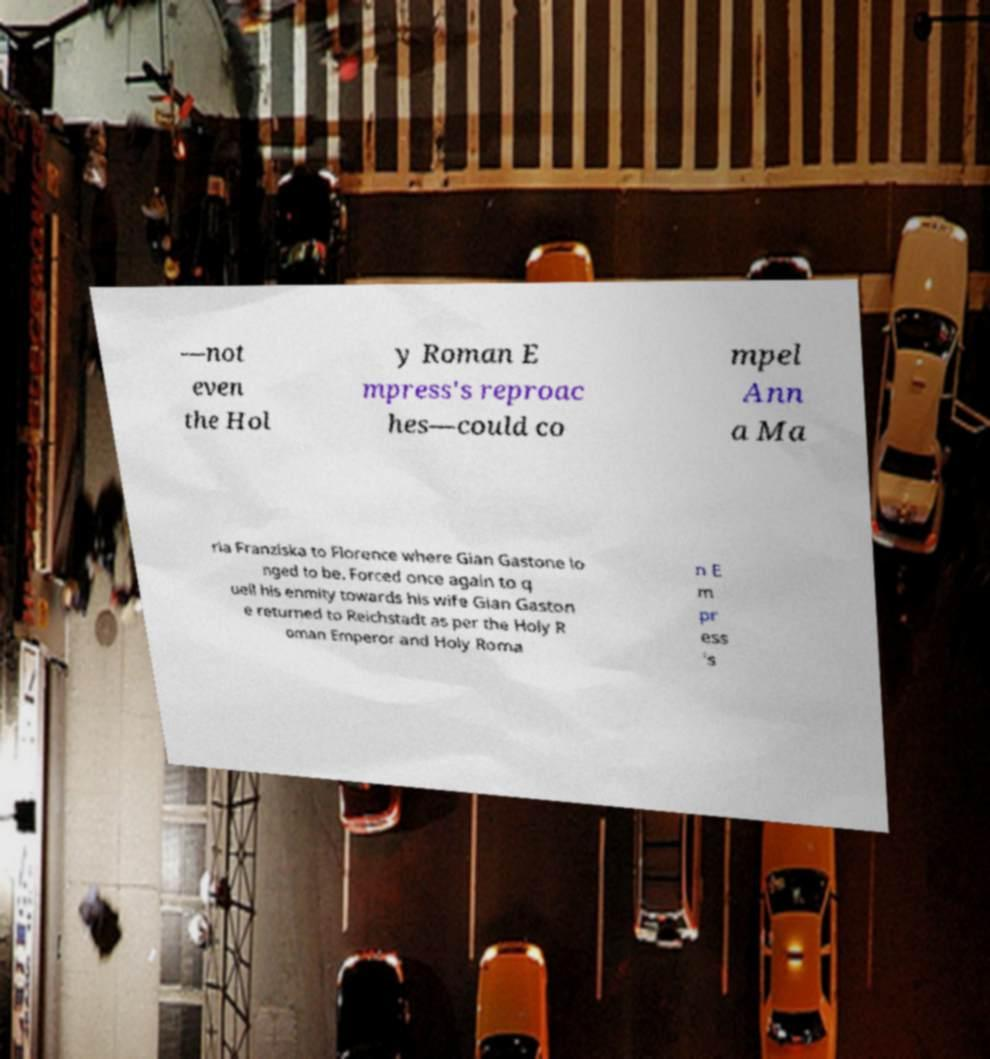Please identify and transcribe the text found in this image. —not even the Hol y Roman E mpress's reproac hes—could co mpel Ann a Ma ria Franziska to Florence where Gian Gastone lo nged to be. Forced once again to q uell his enmity towards his wife Gian Gaston e returned to Reichstadt as per the Holy R oman Emperor and Holy Roma n E m pr ess 's 